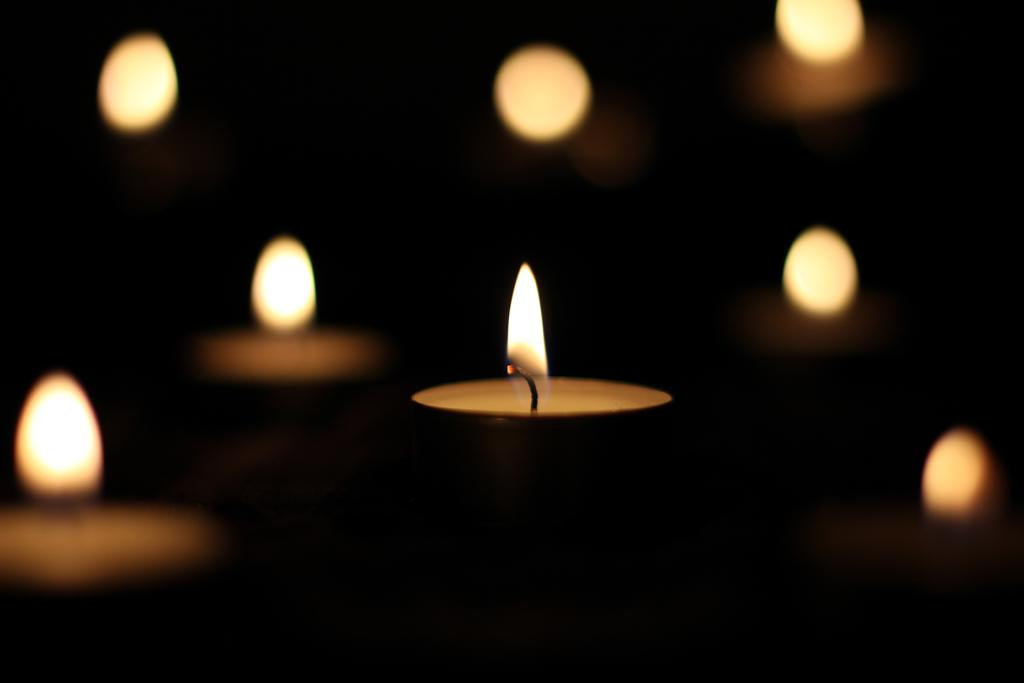What objects are present in the image? There are multiple lamps in the image. Is there any particular lamp that stands out? Yes, one lamp is highlighted among the others. How many thumbs can be seen touching the highlighted lamp in the image? There are no thumbs visible in the image, as it only features lamps. 